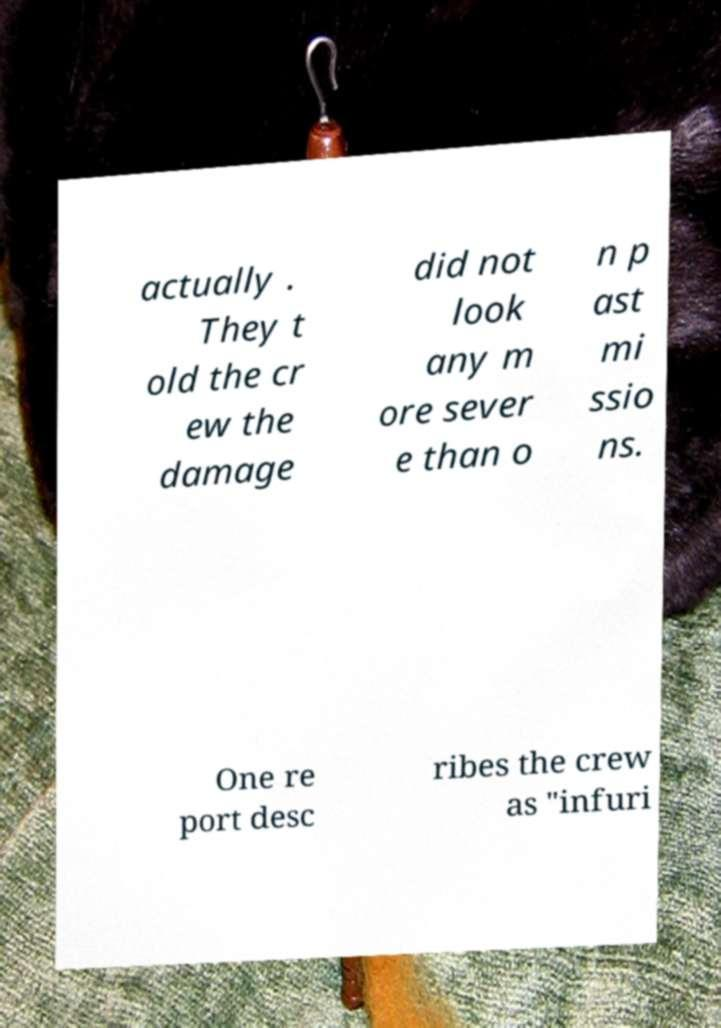Can you accurately transcribe the text from the provided image for me? actually . They t old the cr ew the damage did not look any m ore sever e than o n p ast mi ssio ns. One re port desc ribes the crew as "infuri 